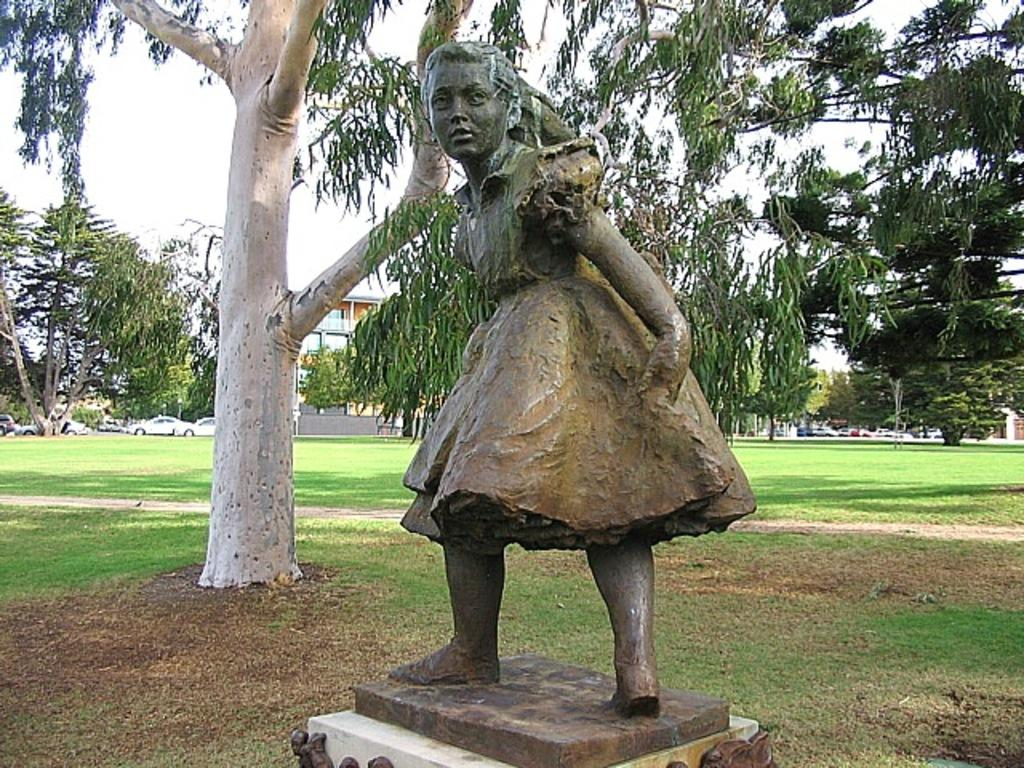What is the main subject in the image? There is a statue in the image. What is the ground like in the image? The ground is visible in the image and has grass on it. What type of vegetation can be seen in the image? There are trees in the image. What type of structures can be seen in the image? There are buildings in the image. What is visible in the background of the image? The sky is visible in the image. What type of slope can be seen in the image? There is no slope present in the image. Can you tell me what color the dad's shirt is in the image? There is no dad or shirt present in the image. What type of gold object can be seen in the image? There is no gold object present in the image. 